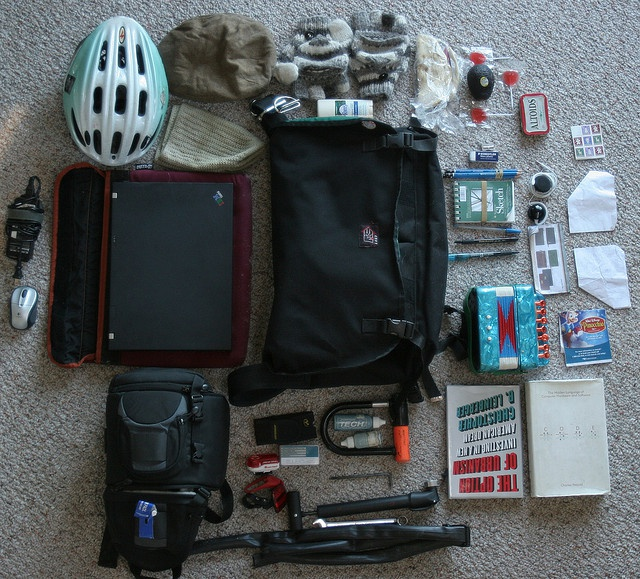Describe the objects in this image and their specific colors. I can see handbag in gray, black, teal, and darkblue tones, laptop in gray, black, darkgray, and navy tones, book in gray, lightgray, and darkgray tones, book in gray, darkgray, black, and brown tones, and mouse in gray, darkgray, and lightblue tones in this image. 